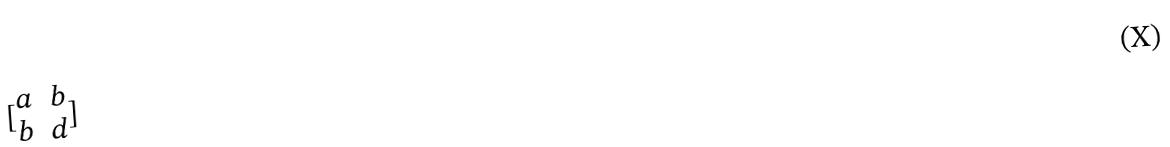<formula> <loc_0><loc_0><loc_500><loc_500>[ \begin{matrix} a & b \\ b & d \end{matrix} ]</formula> 